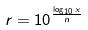<formula> <loc_0><loc_0><loc_500><loc_500>r = 1 0 ^ { \frac { \log _ { 1 0 } x } { n } }</formula> 